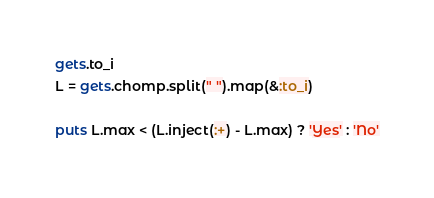<code> <loc_0><loc_0><loc_500><loc_500><_Ruby_>gets.to_i
L = gets.chomp.split(" ").map(&:to_i)

puts L.max < (L.inject(:+) - L.max) ? 'Yes' : 'No'
</code> 